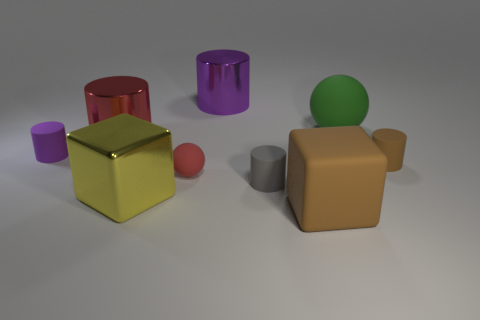There is a big brown thing on the right side of the tiny matte sphere; what is its shape?
Your answer should be compact. Cube. Is there a big rubber cube that is left of the large metallic cylinder right of the large cube that is behind the big brown rubber block?
Your answer should be compact. No. Are there any other things that are the same shape as the purple metal object?
Ensure brevity in your answer.  Yes. Are any big red cylinders visible?
Offer a terse response. Yes. Are the cube to the left of the big purple metal object and the ball that is behind the red rubber object made of the same material?
Offer a terse response. No. There is a brown matte thing that is left of the large thing that is to the right of the large brown matte thing that is in front of the small red matte object; what size is it?
Provide a short and direct response. Large. How many small objects are the same material as the tiny gray cylinder?
Your answer should be very brief. 3. Is the number of matte objects less than the number of matte blocks?
Your answer should be compact. No. What is the size of the red thing that is the same shape as the gray thing?
Your response must be concise. Large. Are the brown object to the right of the matte block and the red cylinder made of the same material?
Your answer should be very brief. No. 